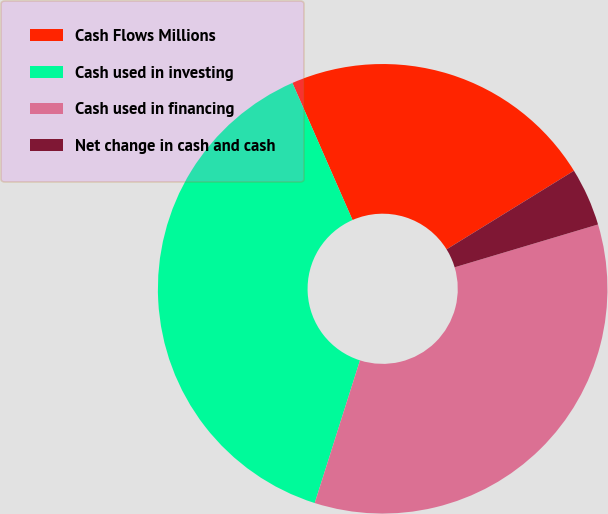Convert chart to OTSL. <chart><loc_0><loc_0><loc_500><loc_500><pie_chart><fcel>Cash Flows Millions<fcel>Cash used in investing<fcel>Cash used in financing<fcel>Net change in cash and cash<nl><fcel>22.78%<fcel>38.54%<fcel>34.51%<fcel>4.18%<nl></chart> 